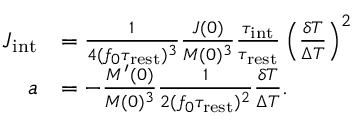<formula> <loc_0><loc_0><loc_500><loc_500>\begin{array} { r l } { J _ { i n t } } & { = \frac { 1 } { 4 ( f _ { 0 } \tau _ { r e s t } ) ^ { 3 } } \frac { J ( 0 ) } { M ( 0 ) ^ { 3 } } \frac { \tau _ { i n t } } { \tau _ { r e s t } } \left ( \frac { \delta T } { \Delta T } \right ) ^ { 2 } } \\ { a } & { = - \frac { M ^ { \prime } ( 0 ) } { M ( 0 ) ^ { 3 } } \frac { 1 } { 2 ( f _ { 0 } \tau _ { r e s t } ) ^ { 2 } } \frac { \delta T } { \Delta T } . } \end{array}</formula> 